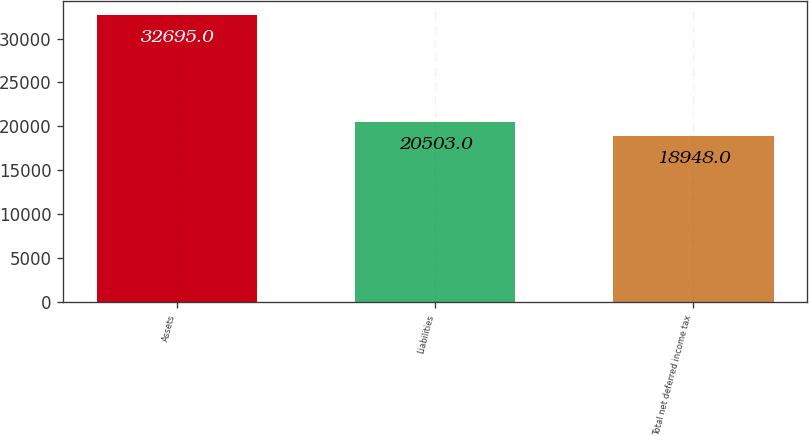Convert chart to OTSL. <chart><loc_0><loc_0><loc_500><loc_500><bar_chart><fcel>Assets<fcel>Liabilities<fcel>Total net deferred income tax<nl><fcel>32695<fcel>20503<fcel>18948<nl></chart> 